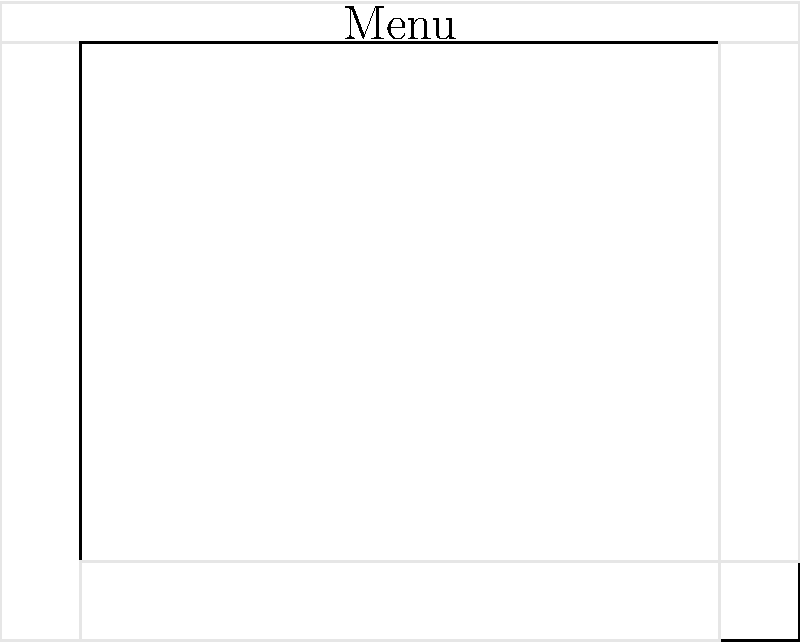Based on the mockup sketch of a 3D modeling software interface, which design principle is most evident in the layout of the main components (menu bar, toolbar, 3D viewport, property panel, and timeline)? To answer this question, let's analyze the layout of the main components in the mockup sketch:

1. Menu bar: Located at the top of the interface, spanning the entire width.
2. Toolbar: Positioned on the left side, occupying the full height of the working area.
3. 3D viewport: Centrally located, taking up the majority of the screen space.
4. Property panel: Placed on the right side, spanning the height of the working area.
5. Timeline: Situated at the bottom, extending across the width of the working area.

This layout demonstrates the principle of spatial organization, specifically:

a) The components are arranged in a logical and predictable manner.
b) Related elements are grouped together (e.g., tools in the toolbar, properties in the panel).
c) The most important element (3D viewport) is given the largest and central space.
d) Less frequently used elements (menu bar, timeline) are placed at the edges.
e) The layout follows a grid-like structure, making it easy for users to navigate.

This arrangement is consistent with the design principle of "Gestalt Law of Proximity," which states that elements close to each other tend to be perceived as a coherent group. It also aligns with the principle of "Visual Hierarchy," emphasizing the most important elements through size and position.

The most evident design principle in this layout is "Spatial Organization," as it effectively organizes the interface elements in a way that is intuitive, efficient, and easy to understand for users working with 3D modeling software.
Answer: Spatial Organization 